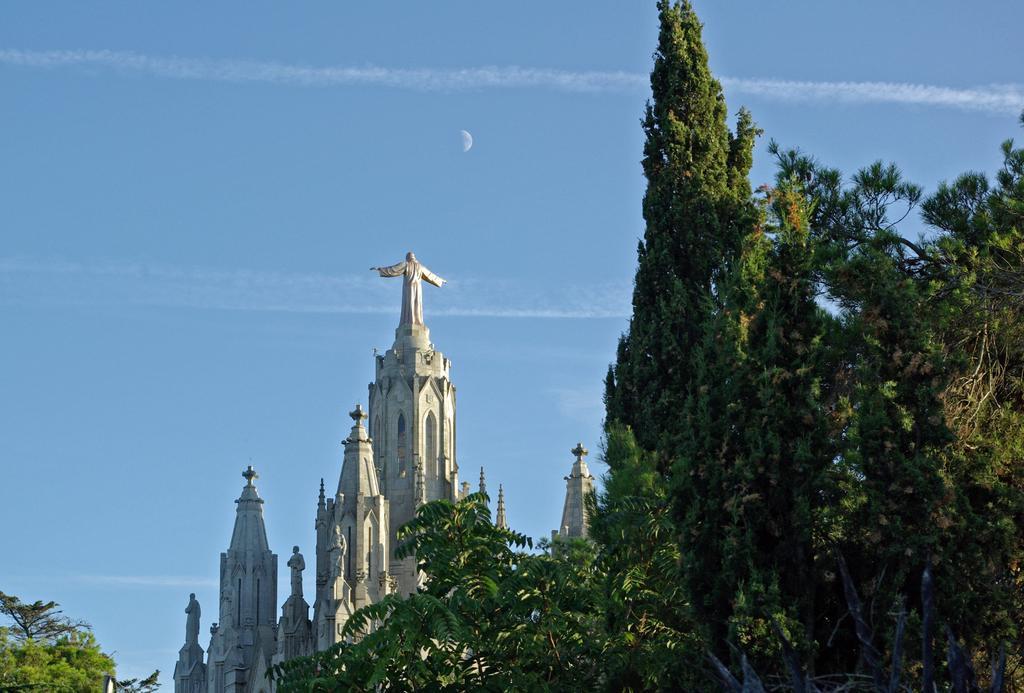In one or two sentences, can you explain what this image depicts? In this image we can see some trees, church and on top of the church there are some statues and top of the image there is clear sky. 